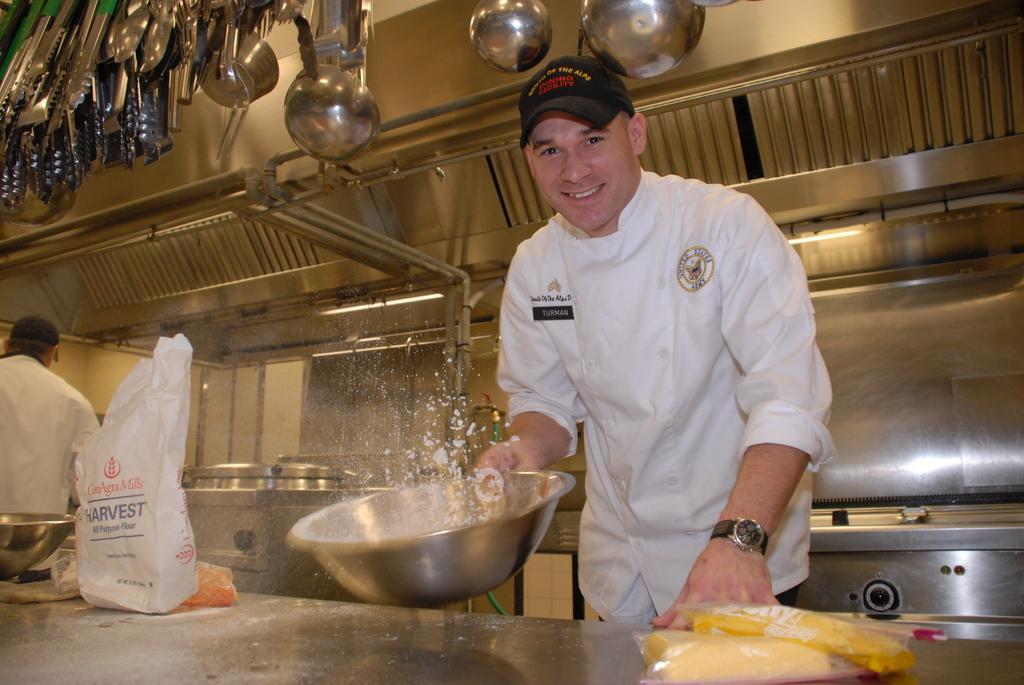Describe this image in one or two sentences. This is an inside view. On the right side there is a man standing, holding a bowl in the hand, smiling and giving pose for the picture. In front of him there is a table on which I can see few packets, bowls and covers. On the left side there is another person. At the back of this man there is another table. In the background, I can see few vessels. It seems like inside view of a Kitchen. At the top there are many spoons. 